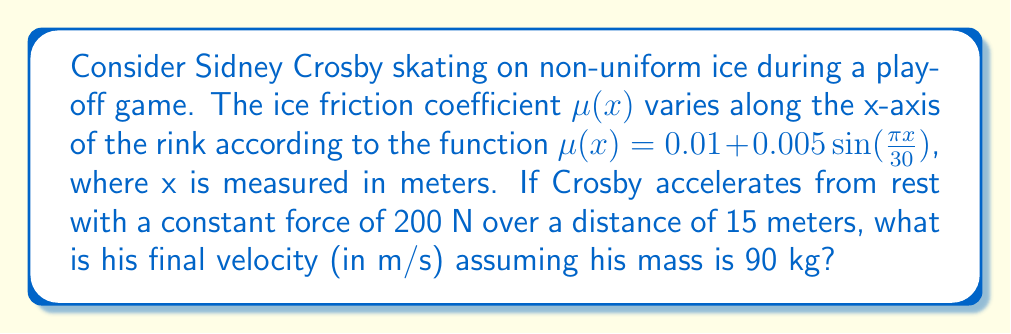Can you answer this question? Let's approach this step-by-step:

1) The work-energy theorem states that the work done on an object equals its change in kinetic energy:

   $W = \Delta KE = \frac{1}{2}mv^2 - \frac{1}{2}mv_0^2$

   Where $v_0 = 0$ (starting from rest), so $\frac{1}{2}mv_0^2 = 0$

2) The work done is the integral of force minus friction over the distance:

   $W = \int_0^{15} (F - f(x)) dx$

   Where $F = 200$ N (constant) and $f(x) = \mu(x)mg$ (friction force)

3) Substituting the friction coefficient:

   $f(x) = (0.01 + 0.005 \sin(\frac{\pi x}{30})) \cdot 90 \cdot 9.8$

4) Now we can set up our integral:

   $\frac{1}{2} \cdot 90 \cdot v^2 = \int_0^{15} (200 - (0.01 + 0.005 \sin(\frac{\pi x}{30})) \cdot 90 \cdot 9.8) dx$

5) Simplifying the right side:

   $\frac{1}{2} \cdot 90 \cdot v^2 = \int_0^{15} (200 - 8.82 - 4.41 \sin(\frac{\pi x}{30})) dx$

6) Evaluating the integral:

   $\frac{1}{2} \cdot 90 \cdot v^2 = [191.18x + 42.14 \cos(\frac{\pi x}{30})]_0^{15}$
   
   $= (2867.7 + 42.14 \cos(\frac{\pi \cdot 15}{30})) - (0 + 42.14)$
   
   $= 2867.7 - 42.14 = 2825.56$

7) Solving for v:

   $v^2 = \frac{2 \cdot 2825.56}{90} = 62.79$

   $v = \sqrt{62.79} \approx 7.92$ m/s
Answer: 7.92 m/s 